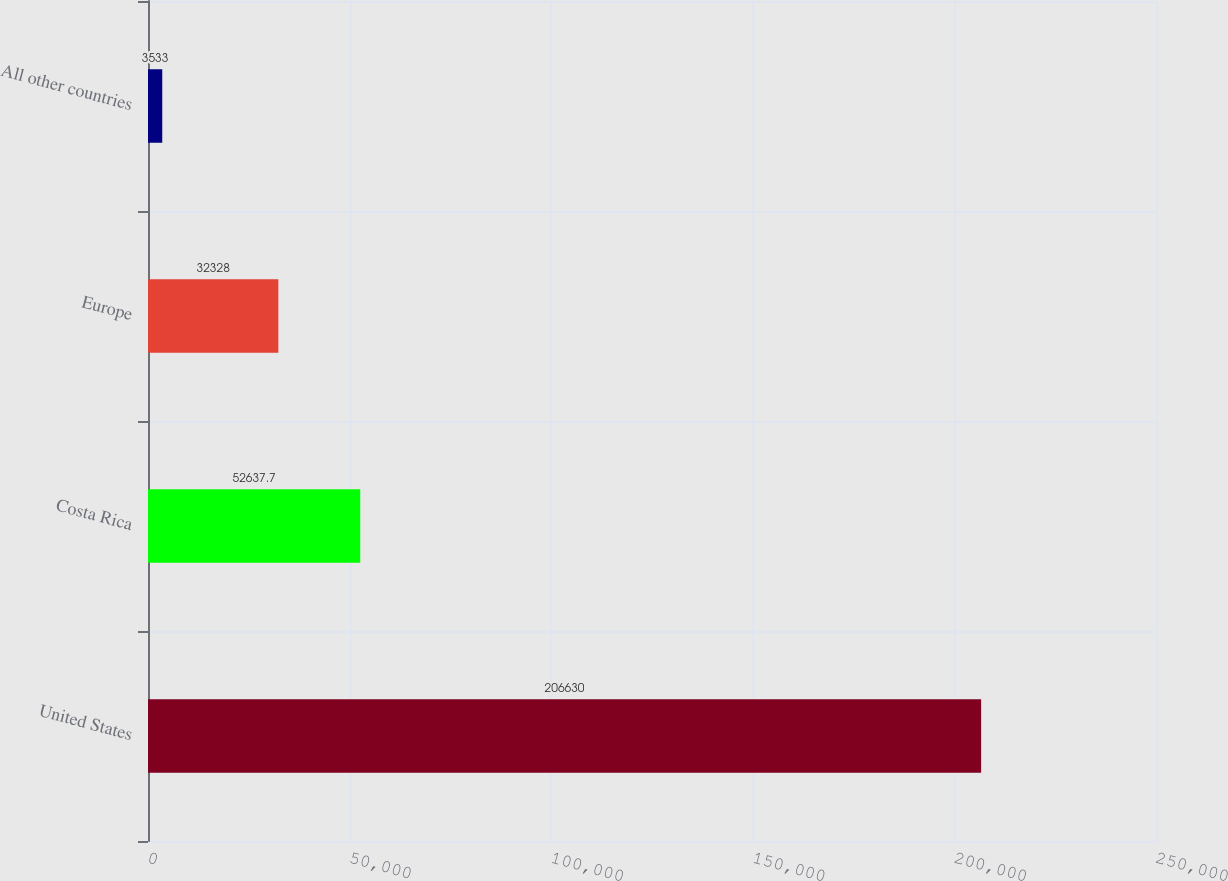Convert chart to OTSL. <chart><loc_0><loc_0><loc_500><loc_500><bar_chart><fcel>United States<fcel>Costa Rica<fcel>Europe<fcel>All other countries<nl><fcel>206630<fcel>52637.7<fcel>32328<fcel>3533<nl></chart> 